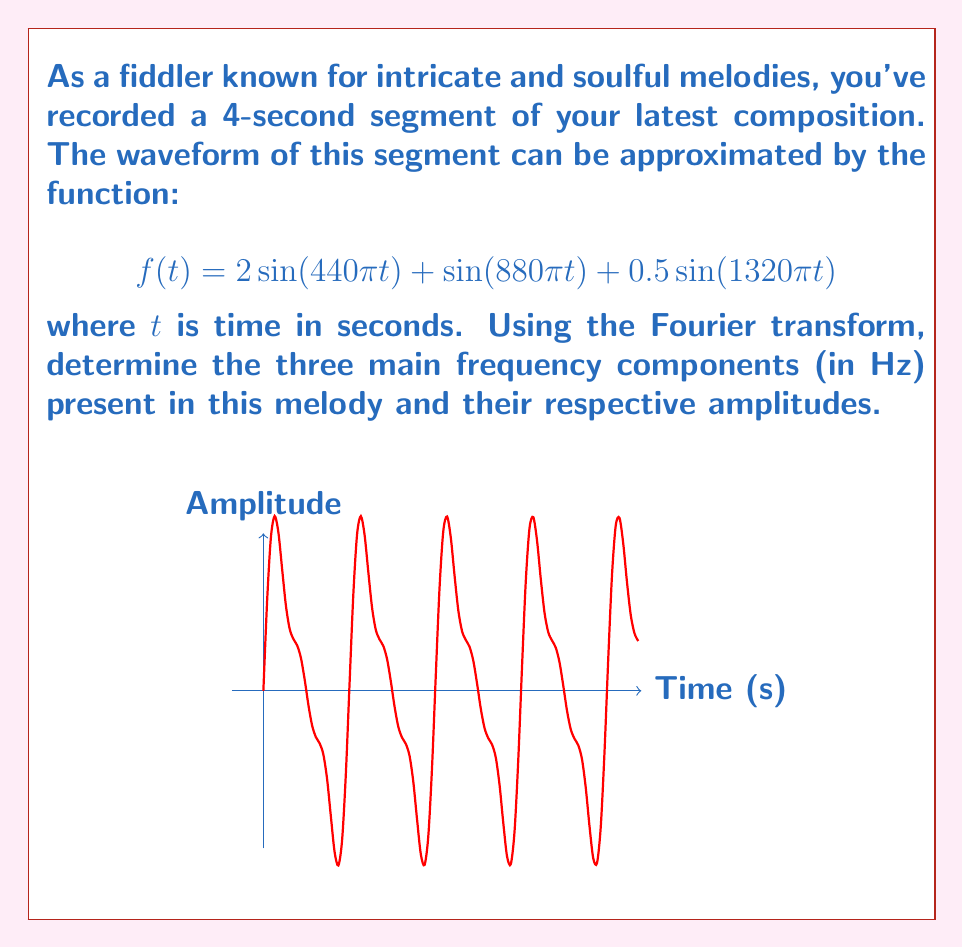Give your solution to this math problem. To solve this problem, we'll follow these steps:

1) Recall that the Fourier transform of a sinusoidal function $A\sin(2\pi ft)$ is a pair of delta functions at frequencies $\pm f$ with amplitude $A/2$.

2) Our function $f(t)$ is a sum of three sinusoids:
   
   $$f(t) = 2\sin(440\pi t) + \sin(880\pi t) + 0.5\sin(1320\pi t)$$

3) Let's analyze each term:

   a) $2\sin(440\pi t)$:
      Frequency: $f_1 = 440\pi/(2\pi) = 220$ Hz
      Amplitude: $A_1 = 2$

   b) $\sin(880\pi t)$:
      Frequency: $f_2 = 880\pi/(2\pi) = 440$ Hz
      Amplitude: $A_2 = 1$

   c) $0.5\sin(1320\pi t)$:
      Frequency: $f_3 = 1320\pi/(2\pi) = 660$ Hz
      Amplitude: $A_3 = 0.5$

4) The Fourier transform will show peaks at these frequencies with amplitudes equal to half of the original amplitudes:

   220 Hz: amplitude $2/2 = 1$
   440 Hz: amplitude $1/2 = 0.5$
   660 Hz: amplitude $0.5/2 = 0.25$

Therefore, the three main frequency components and their amplitudes in the Fourier transform are:
220 Hz with amplitude 1
440 Hz with amplitude 0.5
660 Hz with amplitude 0.25
Answer: 220 Hz (1), 440 Hz (0.5), 660 Hz (0.25) 